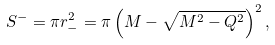Convert formula to latex. <formula><loc_0><loc_0><loc_500><loc_500>S ^ { - } = \pi r ^ { 2 } _ { - } = \pi \left ( M - \sqrt { M ^ { 2 } - Q ^ { 2 } } \right ) ^ { 2 } ,</formula> 